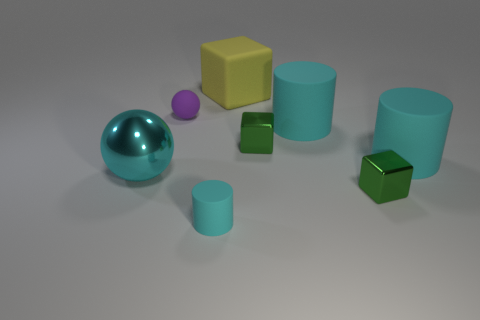The cyan matte thing that is the same size as the purple rubber object is what shape?
Provide a short and direct response. Cylinder. Is there another yellow matte object of the same shape as the big yellow thing?
Your answer should be very brief. No. There is a rubber thing that is behind the purple matte ball that is to the left of the big rubber cube; what is its shape?
Ensure brevity in your answer.  Cube. What is the shape of the purple thing?
Ensure brevity in your answer.  Sphere. What is the material of the green cube that is behind the small cube that is in front of the object on the left side of the tiny matte ball?
Keep it short and to the point. Metal. What number of other things are the same material as the yellow cube?
Offer a very short reply. 4. How many small balls are behind the purple rubber object that is to the left of the small cyan thing?
Your answer should be compact. 0. How many cubes are small green shiny things or purple objects?
Give a very brief answer. 2. What color is the rubber thing that is to the left of the large yellow block and in front of the purple matte object?
Give a very brief answer. Cyan. Is there anything else that has the same color as the rubber ball?
Offer a terse response. No. 